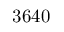Convert formula to latex. <formula><loc_0><loc_0><loc_500><loc_500>3 6 4 0</formula> 